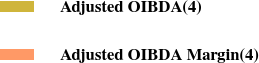Convert chart to OTSL. <chart><loc_0><loc_0><loc_500><loc_500><pie_chart><fcel>Adjusted OIBDA(4)<fcel>Adjusted OIBDA Margin(4)<nl><fcel>100.0%<fcel>0.0%<nl></chart> 